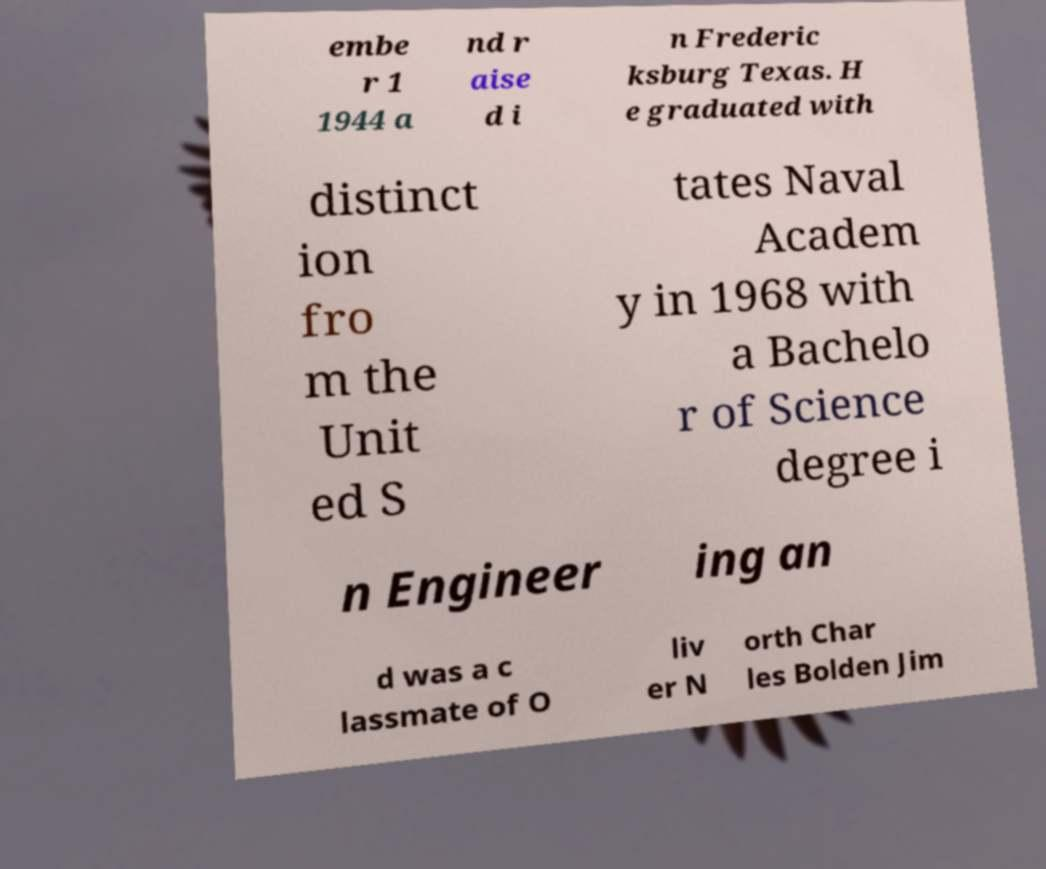Can you accurately transcribe the text from the provided image for me? embe r 1 1944 a nd r aise d i n Frederic ksburg Texas. H e graduated with distinct ion fro m the Unit ed S tates Naval Academ y in 1968 with a Bachelo r of Science degree i n Engineer ing an d was a c lassmate of O liv er N orth Char les Bolden Jim 